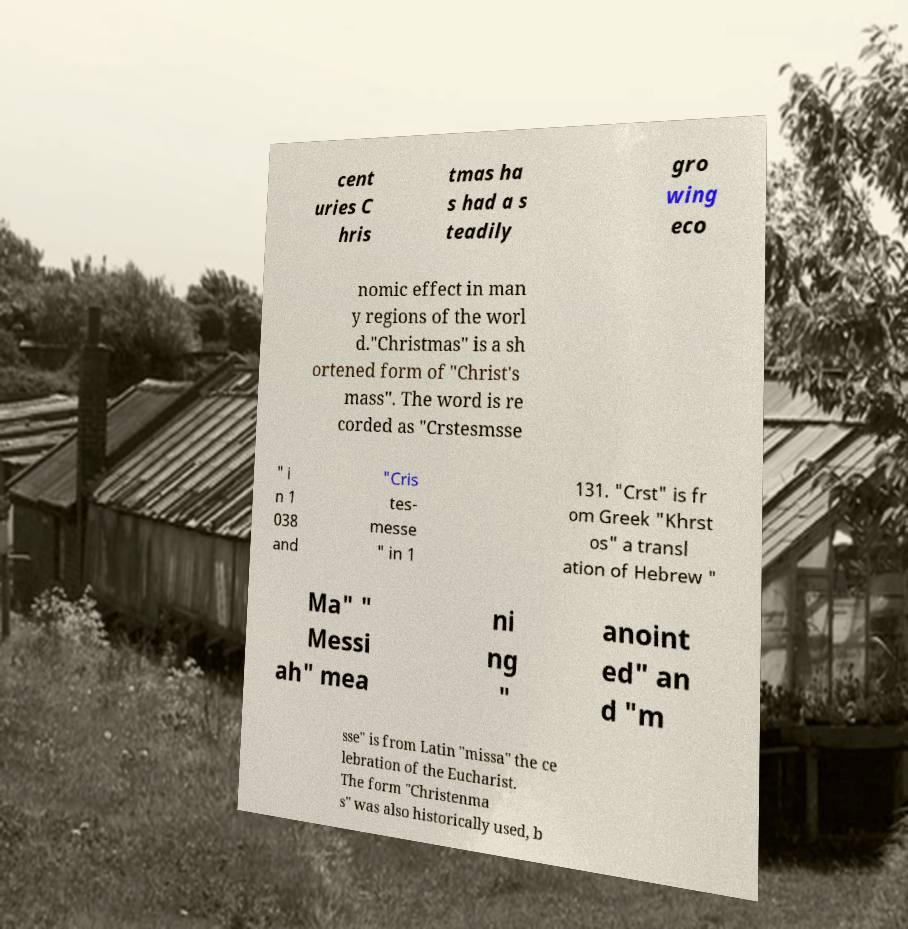For documentation purposes, I need the text within this image transcribed. Could you provide that? cent uries C hris tmas ha s had a s teadily gro wing eco nomic effect in man y regions of the worl d."Christmas" is a sh ortened form of "Christ's mass". The word is re corded as "Crstesmsse " i n 1 038 and "Cris tes- messe " in 1 131. "Crst" is fr om Greek "Khrst os" a transl ation of Hebrew " Ma" " Messi ah" mea ni ng " anoint ed" an d "m sse" is from Latin "missa" the ce lebration of the Eucharist. The form "Christenma s" was also historically used, b 